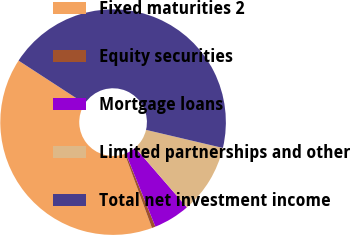<chart> <loc_0><loc_0><loc_500><loc_500><pie_chart><fcel>Fixed maturities 2<fcel>Equity securities<fcel>Mortgage loans<fcel>Limited partnerships and other<fcel>Total net investment income<nl><fcel>39.78%<fcel>0.52%<fcel>5.24%<fcel>9.96%<fcel>44.5%<nl></chart> 